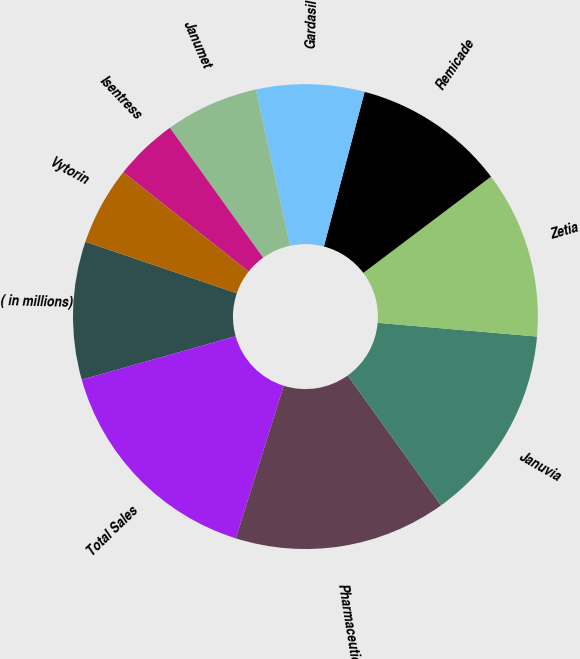<chart> <loc_0><loc_0><loc_500><loc_500><pie_chart><fcel>( in millions)<fcel>Total Sales<fcel>Pharmaceutical<fcel>Januvia<fcel>Zetia<fcel>Remicade<fcel>Gardasil<fcel>Janumet<fcel>Isentress<fcel>Vytorin<nl><fcel>9.59%<fcel>15.79%<fcel>14.75%<fcel>13.72%<fcel>11.65%<fcel>10.62%<fcel>7.52%<fcel>6.49%<fcel>4.42%<fcel>5.45%<nl></chart> 